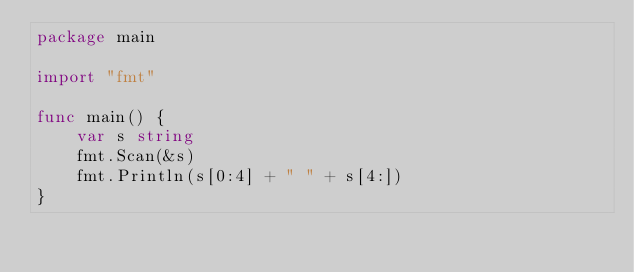<code> <loc_0><loc_0><loc_500><loc_500><_Go_>package main

import "fmt"

func main() {
	var s string
	fmt.Scan(&s)
	fmt.Println(s[0:4] + " " + s[4:])
}
</code> 